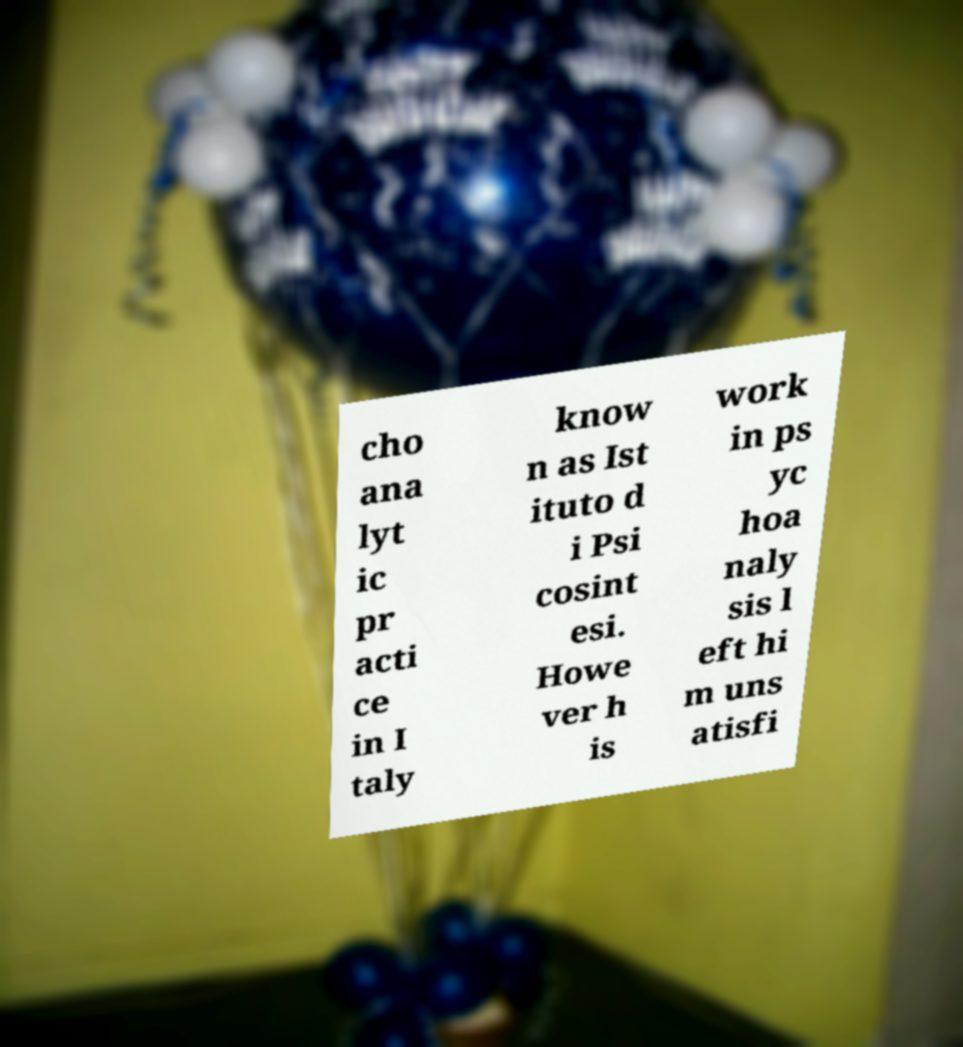Could you assist in decoding the text presented in this image and type it out clearly? cho ana lyt ic pr acti ce in I taly know n as Ist ituto d i Psi cosint esi. Howe ver h is work in ps yc hoa naly sis l eft hi m uns atisfi 